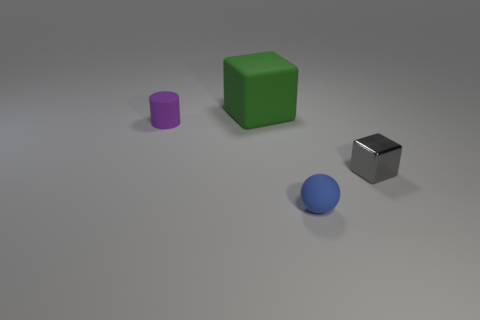Add 3 small purple rubber objects. How many objects exist? 7 Subtract all spheres. How many objects are left? 3 Subtract all small blue rubber objects. Subtract all large cyan things. How many objects are left? 3 Add 3 purple cylinders. How many purple cylinders are left? 4 Add 1 large brown spheres. How many large brown spheres exist? 1 Subtract 0 yellow cylinders. How many objects are left? 4 